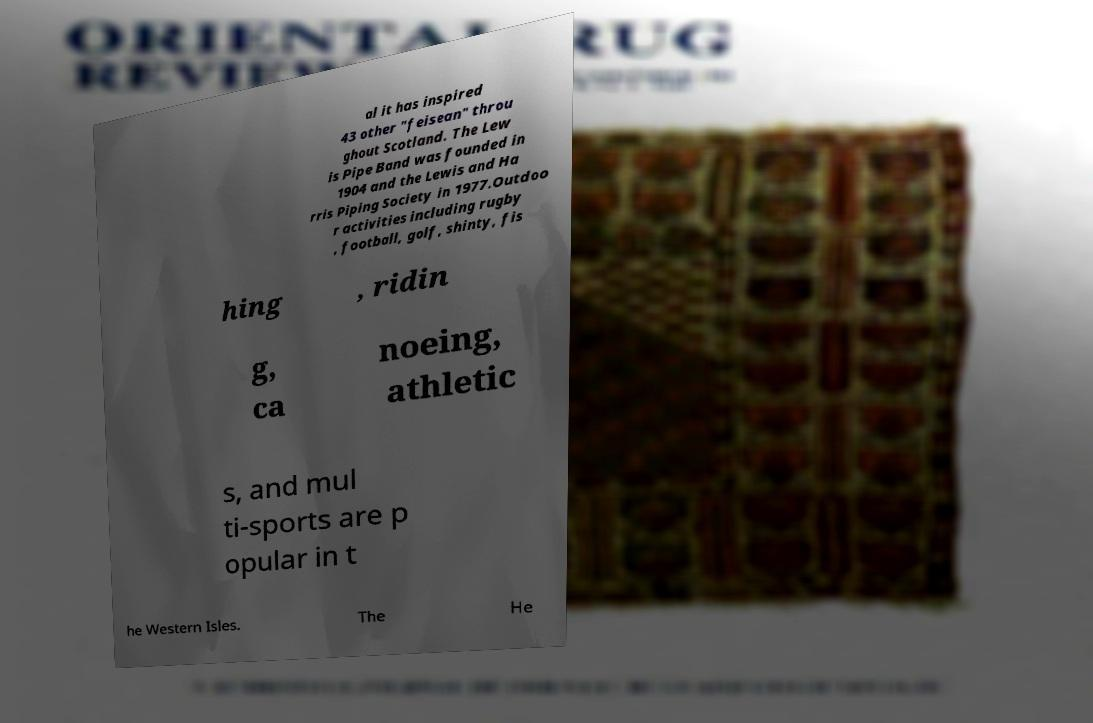Please identify and transcribe the text found in this image. al it has inspired 43 other "feisean" throu ghout Scotland. The Lew is Pipe Band was founded in 1904 and the Lewis and Ha rris Piping Society in 1977.Outdoo r activities including rugby , football, golf, shinty, fis hing , ridin g, ca noeing, athletic s, and mul ti-sports are p opular in t he Western Isles. The He 